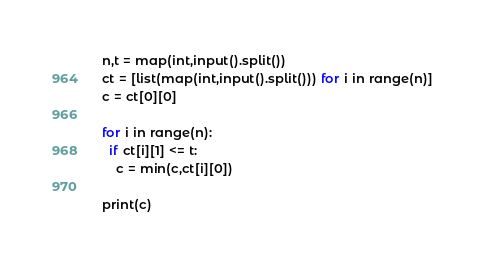Convert code to text. <code><loc_0><loc_0><loc_500><loc_500><_Python_>n,t = map(int,input().split())
ct = [list(map(int,input().split())) for i in range(n)]
c = ct[0][0]

for i in range(n):
  if ct[i][1] <= t:
    c = min(c,ct[i][0])
    
print(c)</code> 